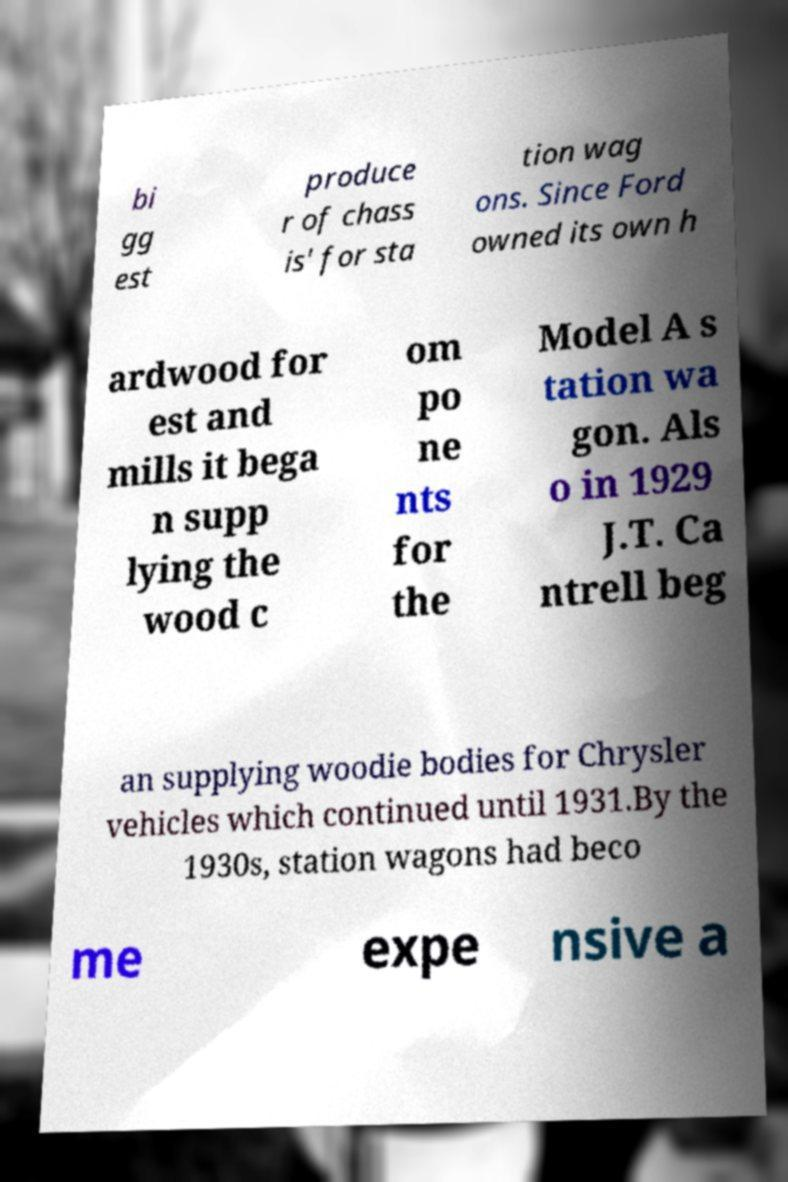Could you extract and type out the text from this image? bi gg est produce r of chass is' for sta tion wag ons. Since Ford owned its own h ardwood for est and mills it bega n supp lying the wood c om po ne nts for the Model A s tation wa gon. Als o in 1929 J.T. Ca ntrell beg an supplying woodie bodies for Chrysler vehicles which continued until 1931.By the 1930s, station wagons had beco me expe nsive a 